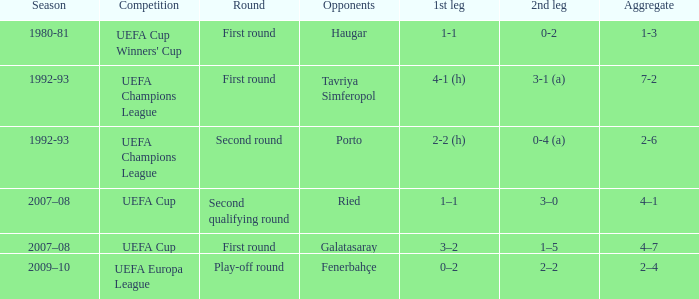 what's the aggregate where 1st leg is 3–2 4–7. 